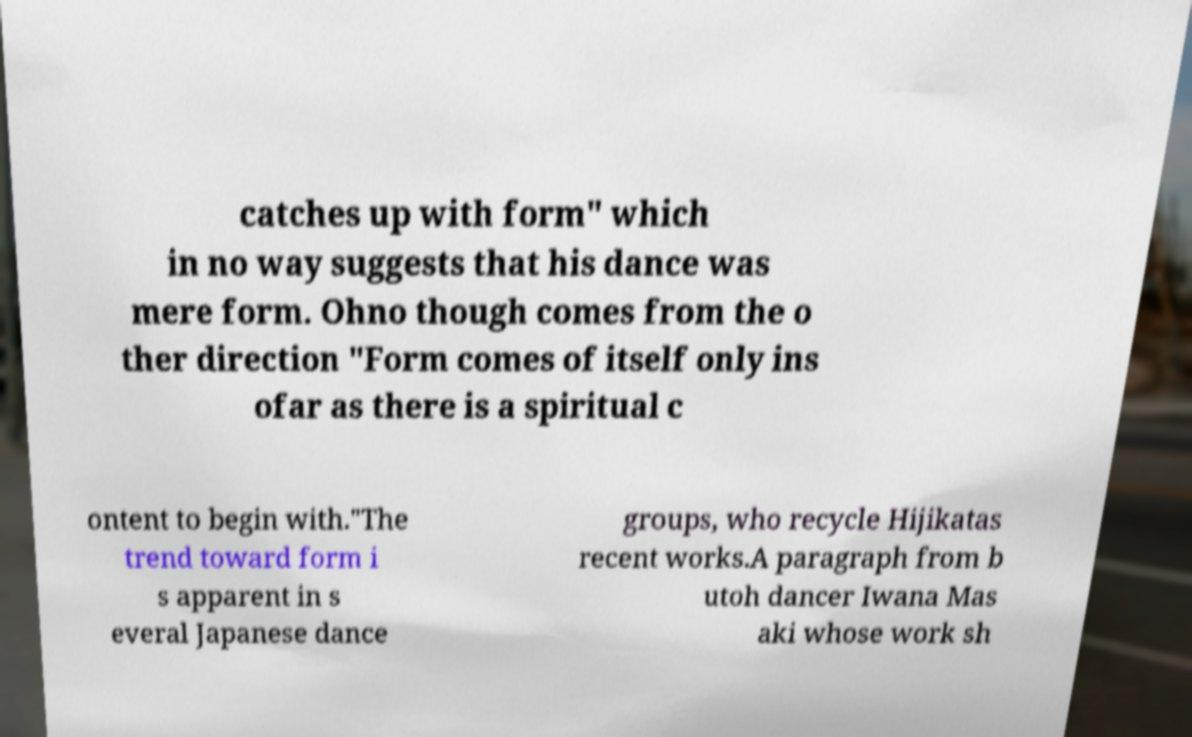Could you assist in decoding the text presented in this image and type it out clearly? catches up with form" which in no way suggests that his dance was mere form. Ohno though comes from the o ther direction "Form comes of itself only ins ofar as there is a spiritual c ontent to begin with."The trend toward form i s apparent in s everal Japanese dance groups, who recycle Hijikatas recent works.A paragraph from b utoh dancer Iwana Mas aki whose work sh 